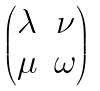Convert formula to latex. <formula><loc_0><loc_0><loc_500><loc_500>\begin{pmatrix} \lambda & \nu \\ \mu & \omega \end{pmatrix}</formula> 